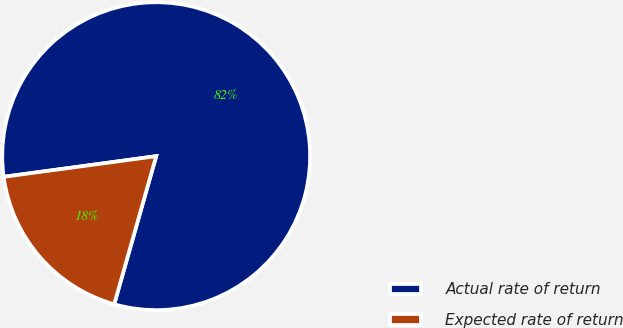Convert chart. <chart><loc_0><loc_0><loc_500><loc_500><pie_chart><fcel>Actual rate of return<fcel>Expected rate of return<nl><fcel>81.54%<fcel>18.46%<nl></chart> 